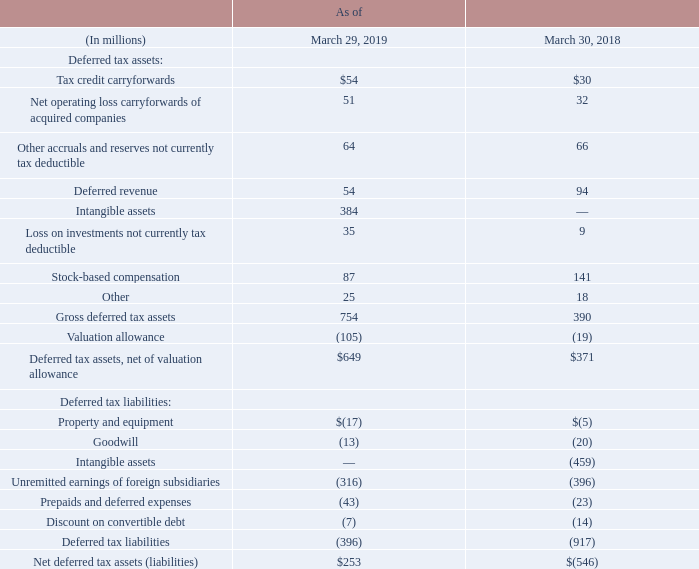The principal components of deferred tax assets and liabilities are as follows:
The valuation allowance provided against our deferred tax assets as of March 29, 2019, increased primarily due to a corresponding increase in unrealized capital losses from equity investments, certain acquired tax loss and tax credits carryforwards, and California research and development credits. Based on our current operations, these attributes are not expected to be realized, and a valuation allowance has been recorded to offset them.
As of March 29, 2019, we have U.S. federal net operating losses attributable to various acquired companies of approximately $147 million, which, if not used, will expire between fiscal 2020 and 2037. We have U.S. federal research and development credits of approximately $11 million. The research and development credits, if not used, will expire between fiscal 2020 and 2036. $89 million of the net operating loss carryforwards and $11 million of the U.S. federal research and development tax credits are subject to limitations which currently prevent their use, and therefore these attributes are not expected to be realized. The remaining net operating loss carryforwards and U.S. federal research and development tax credits are subject to an annual limitation under U.S. federal tax regulations but are expected to be fully realized. We have $3 million of foreign tax credits which, if not used, will expire beginning in fiscal 2028. Furthermore, we have U.S. state net operating loss and credit carryforwards attributable to various acquired companies of approximately $68 million and $51 million, respectively. If not used, our U.S. state net operating losses will expire between fiscal 2020 and 2037, and the majority of our U.S. state credit carryforwards can be carried forward indefinitely. In addition, we have foreign net operating loss carryforwards attributable to various foreign companies of approximately $118 million, $24 million of which relate to Japan, and will expire beginning in fiscal 2028, and the rest of which, under current applicable foreign tax law, can be carried forward indefinitely.
What does the table show? The principal components of deferred tax assets and liabilities. As of March 30, 2018, what is the  Tax credit carryforwards?
Answer scale should be: million. $30. What is the reason for the increase in valuation allowance provided against deferred tax assets as of March 29, 2019? Due to a corresponding increase in unrealized capital losses from equity investments, certain acquired tax loss and tax credits carryforwards, and california research and development credits. What is the total Net deferred tax assets (liabilities) for as of  March 29, 2019 and March 30, 2018?
Answer scale should be: million. 253+(-546)
Answer: -293. What is the average Net deferred tax assets (liabilities) for as of  March 29, 2019 and  March 30, 2018?
Answer scale should be: million. (253+(-546))/2
Answer: -146.5. As of March 29, 2019, What is Intangible assets expressed as a percentage of  Gross deferred tax assets?
Answer scale should be: percent. 384/754
Answer: 50.93. 